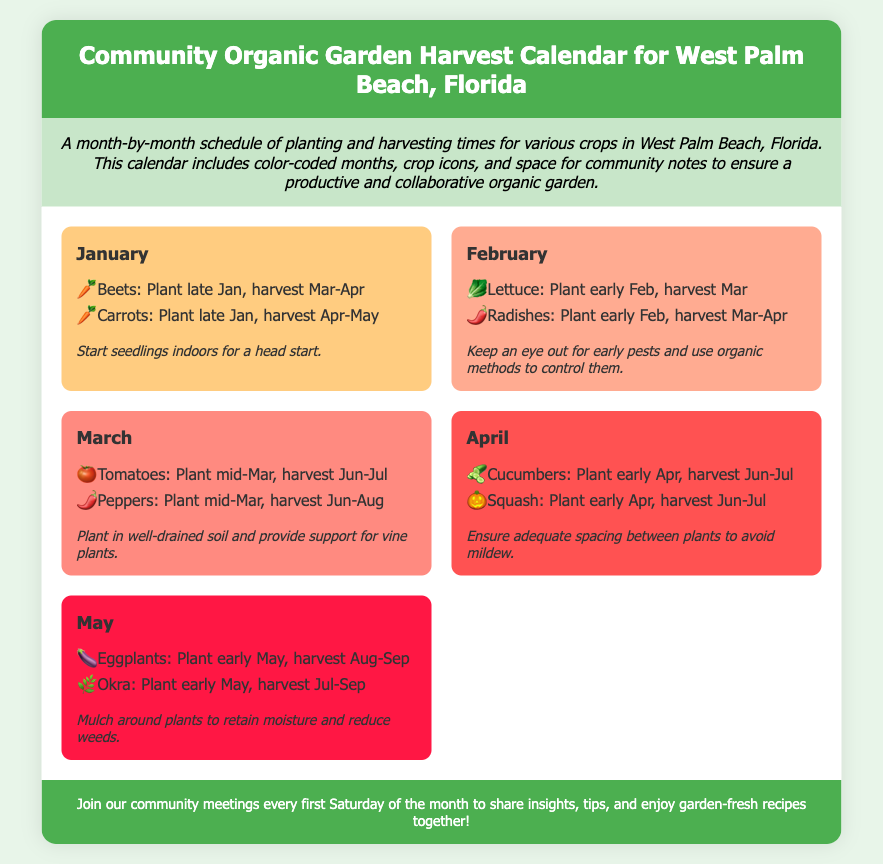What month is indicated for planting carrots? The document states that carrots are to be planted in late January.
Answer: Late January Which crop can be harvested in March? According to the calendar, lettuce can be harvested in March.
Answer: Lettuce What color represents the month of April? The month of April is represented by the color #FF5252.
Answer: #FF5252 How often are community meetings held? The document mentions that community meetings are held every first Saturday of the month.
Answer: Every first Saturday What is a recommended action for seedlings in January? The community notes suggest starting seedlings indoors for a head start in January.
Answer: Start seedlings indoors 